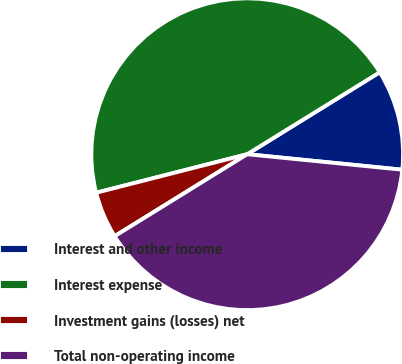<chart> <loc_0><loc_0><loc_500><loc_500><pie_chart><fcel>Interest and other income<fcel>Interest expense<fcel>Investment gains (losses) net<fcel>Total non-operating income<nl><fcel>10.4%<fcel>45.16%<fcel>4.84%<fcel>39.6%<nl></chart> 